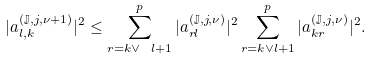Convert formula to latex. <formula><loc_0><loc_0><loc_500><loc_500>| a _ { l , k } ^ { ( \mathbb { J } , j , \nu + 1 ) } | ^ { 2 } \leq \sum _ { r = k \vee \ l + 1 } ^ { p } | a _ { r l } ^ { ( \mathbb { J } , j , \nu ) } | ^ { 2 } \sum _ { r = k \vee l + 1 } ^ { p } | a _ { k r } ^ { ( \mathbb { J } , j , \nu ) } | ^ { 2 } .</formula> 